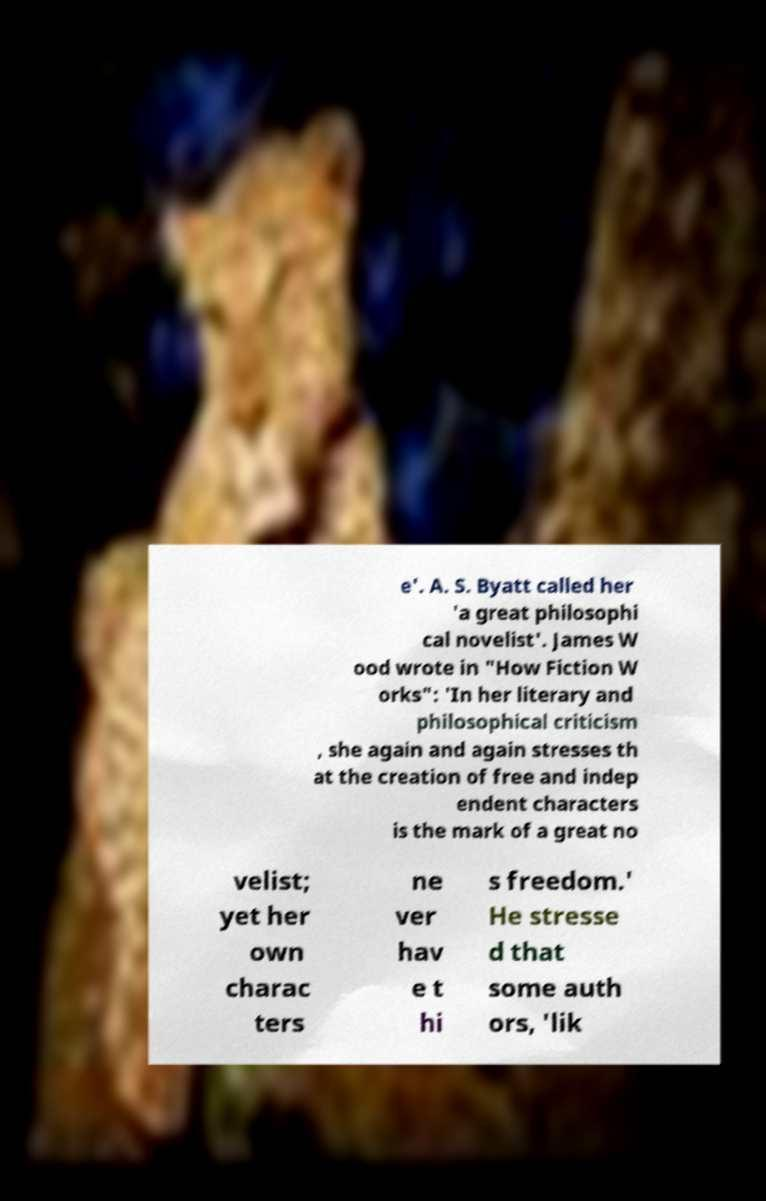What messages or text are displayed in this image? I need them in a readable, typed format. e'. A. S. Byatt called her 'a great philosophi cal novelist'. James W ood wrote in "How Fiction W orks": 'In her literary and philosophical criticism , she again and again stresses th at the creation of free and indep endent characters is the mark of a great no velist; yet her own charac ters ne ver hav e t hi s freedom.' He stresse d that some auth ors, 'lik 